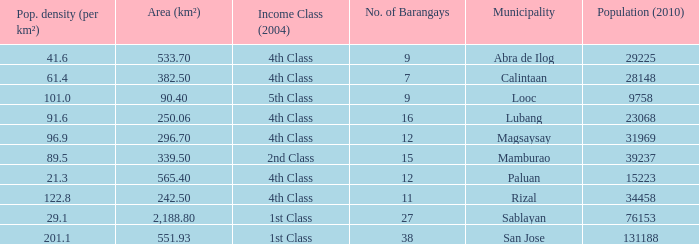List the population density per kilometer for the city of calintaan? 61.4. 